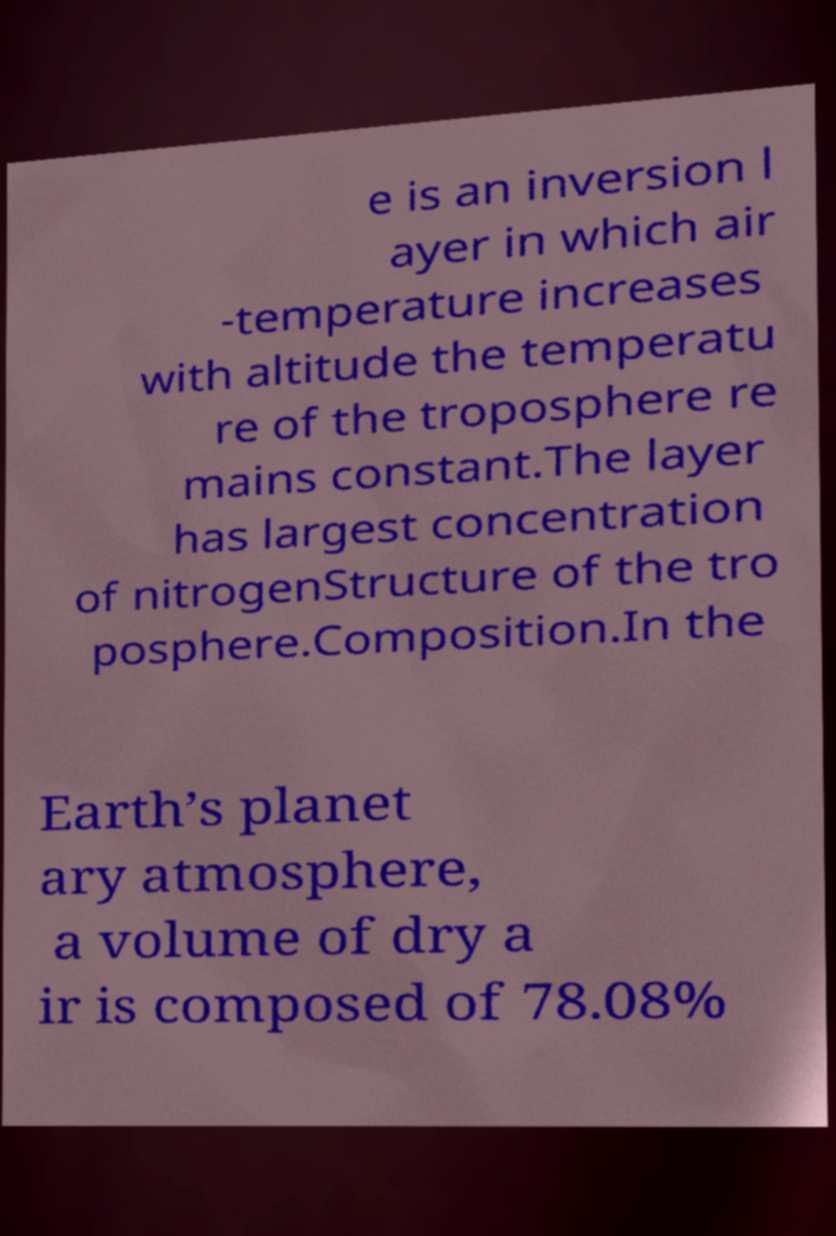Can you accurately transcribe the text from the provided image for me? e is an inversion l ayer in which air -temperature increases with altitude the temperatu re of the troposphere re mains constant.The layer has largest concentration of nitrogenStructure of the tro posphere.Composition.In the Earth’s planet ary atmosphere, a volume of dry a ir is composed of 78.08% 